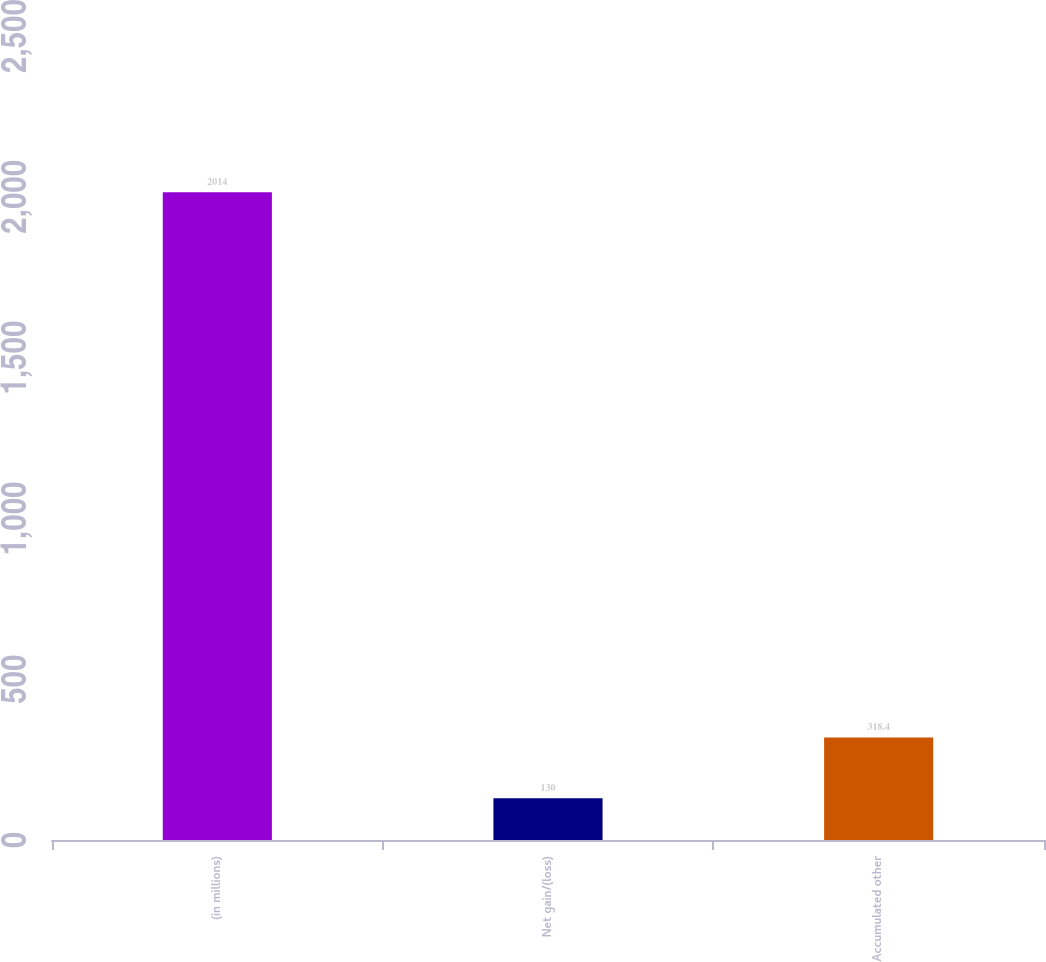Convert chart to OTSL. <chart><loc_0><loc_0><loc_500><loc_500><bar_chart><fcel>(in millions)<fcel>Net gain/(loss)<fcel>Accumulated other<nl><fcel>2014<fcel>130<fcel>318.4<nl></chart> 